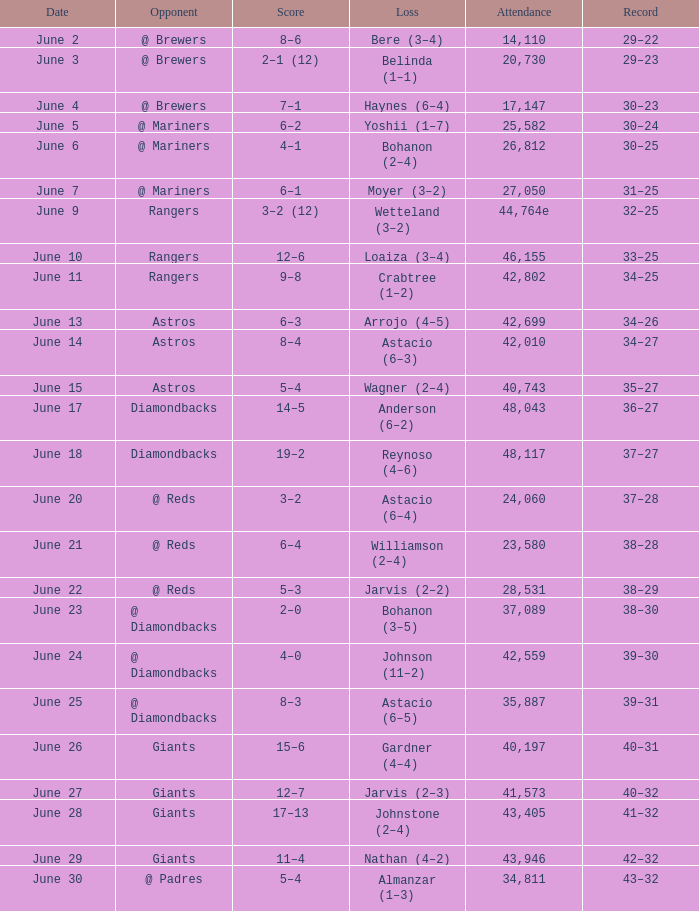What's the record when the attendance was 41,573? 40–32. 